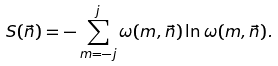Convert formula to latex. <formula><loc_0><loc_0><loc_500><loc_500>S ( \vec { n } ) = - \sum _ { m = - j } ^ { j } \omega ( m , \vec { n } ) \ln \omega ( m , \vec { n } ) .</formula> 